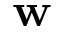Convert formula to latex. <formula><loc_0><loc_0><loc_500><loc_500>w</formula> 